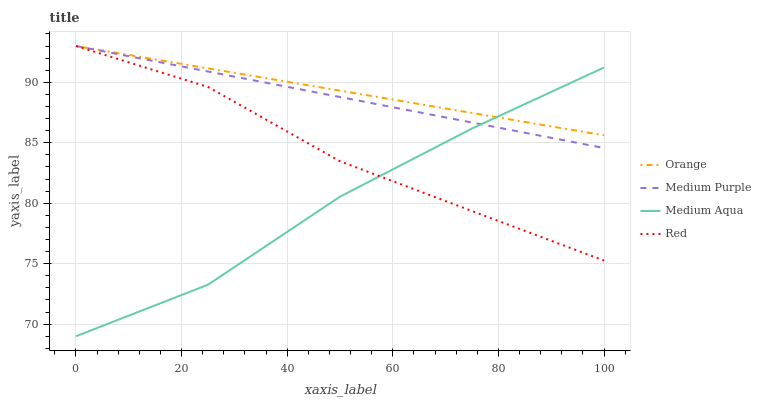Does Medium Aqua have the minimum area under the curve?
Answer yes or no. Yes. Does Orange have the maximum area under the curve?
Answer yes or no. Yes. Does Medium Purple have the minimum area under the curve?
Answer yes or no. No. Does Medium Purple have the maximum area under the curve?
Answer yes or no. No. Is Orange the smoothest?
Answer yes or no. Yes. Is Medium Aqua the roughest?
Answer yes or no. Yes. Is Medium Purple the smoothest?
Answer yes or no. No. Is Medium Purple the roughest?
Answer yes or no. No. Does Medium Aqua have the lowest value?
Answer yes or no. Yes. Does Medium Purple have the lowest value?
Answer yes or no. No. Does Red have the highest value?
Answer yes or no. Yes. Does Medium Aqua have the highest value?
Answer yes or no. No. Does Medium Aqua intersect Red?
Answer yes or no. Yes. Is Medium Aqua less than Red?
Answer yes or no. No. Is Medium Aqua greater than Red?
Answer yes or no. No. 